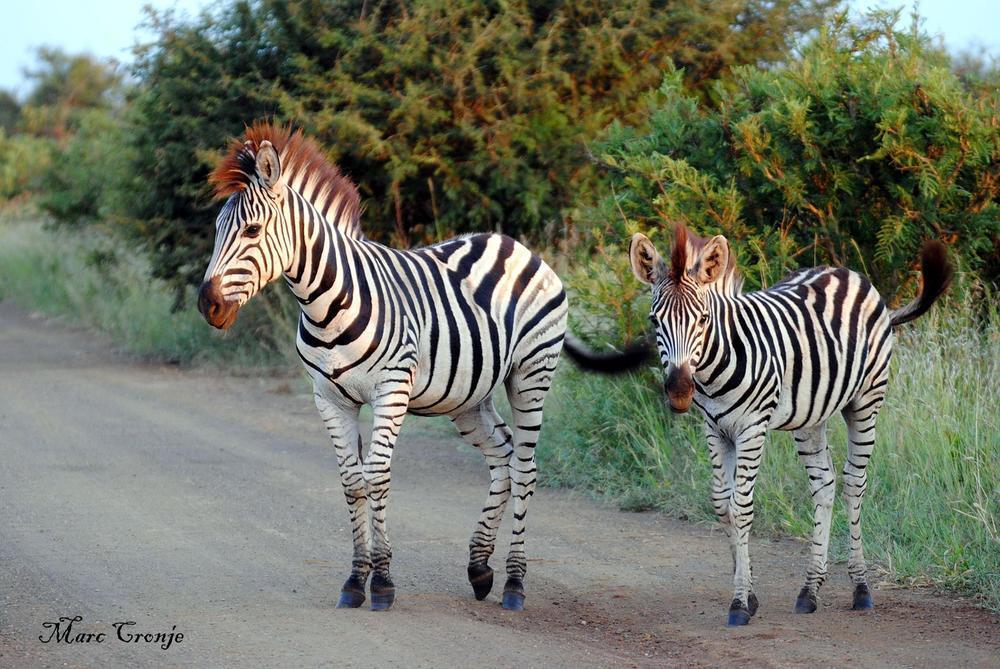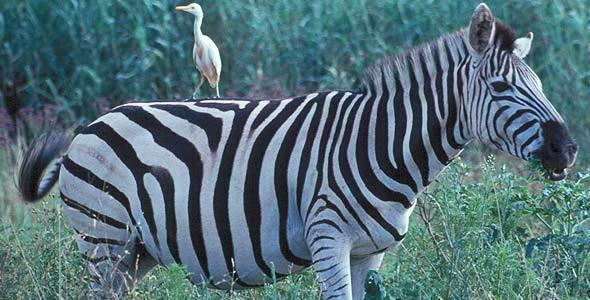The first image is the image on the left, the second image is the image on the right. Evaluate the accuracy of this statement regarding the images: "A taller standing zebra is left of a smaller standing zebra in one image, and the other image shows a zebra standing with its body turned rightward.". Is it true? Answer yes or no. Yes. The first image is the image on the left, the second image is the image on the right. For the images displayed, is the sentence "There is more than one species of animal present." factually correct? Answer yes or no. Yes. 